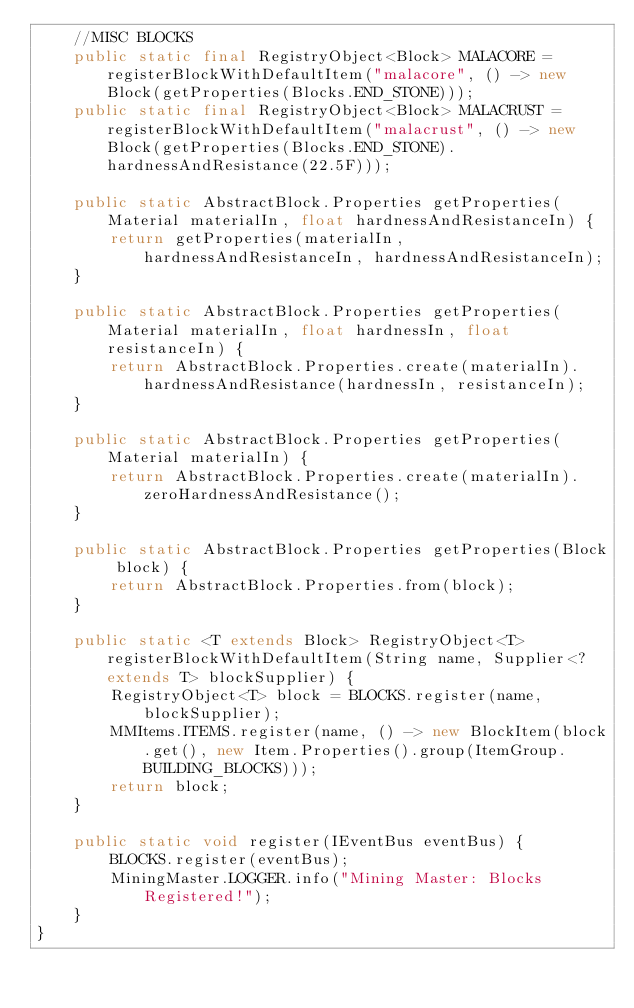<code> <loc_0><loc_0><loc_500><loc_500><_Java_>    //MISC BLOCKS
    public static final RegistryObject<Block> MALACORE = registerBlockWithDefaultItem("malacore", () -> new Block(getProperties(Blocks.END_STONE)));
    public static final RegistryObject<Block> MALACRUST = registerBlockWithDefaultItem("malacrust", () -> new Block(getProperties(Blocks.END_STONE).hardnessAndResistance(22.5F)));

    public static AbstractBlock.Properties getProperties(Material materialIn, float hardnessAndResistanceIn) {
        return getProperties(materialIn, hardnessAndResistanceIn, hardnessAndResistanceIn);
    }

    public static AbstractBlock.Properties getProperties(Material materialIn, float hardnessIn, float resistanceIn) {
        return AbstractBlock.Properties.create(materialIn).hardnessAndResistance(hardnessIn, resistanceIn);
    }

    public static AbstractBlock.Properties getProperties(Material materialIn) {
        return AbstractBlock.Properties.create(materialIn).zeroHardnessAndResistance();
    }

    public static AbstractBlock.Properties getProperties(Block block) {
        return AbstractBlock.Properties.from(block);
    }

    public static <T extends Block> RegistryObject<T> registerBlockWithDefaultItem(String name, Supplier<? extends T> blockSupplier) {
        RegistryObject<T> block = BLOCKS.register(name, blockSupplier);
        MMItems.ITEMS.register(name, () -> new BlockItem(block.get(), new Item.Properties().group(ItemGroup.BUILDING_BLOCKS)));
        return block;
    }

    public static void register(IEventBus eventBus) {
        BLOCKS.register(eventBus);
        MiningMaster.LOGGER.info("Mining Master: Blocks Registered!");
    }
}
</code> 